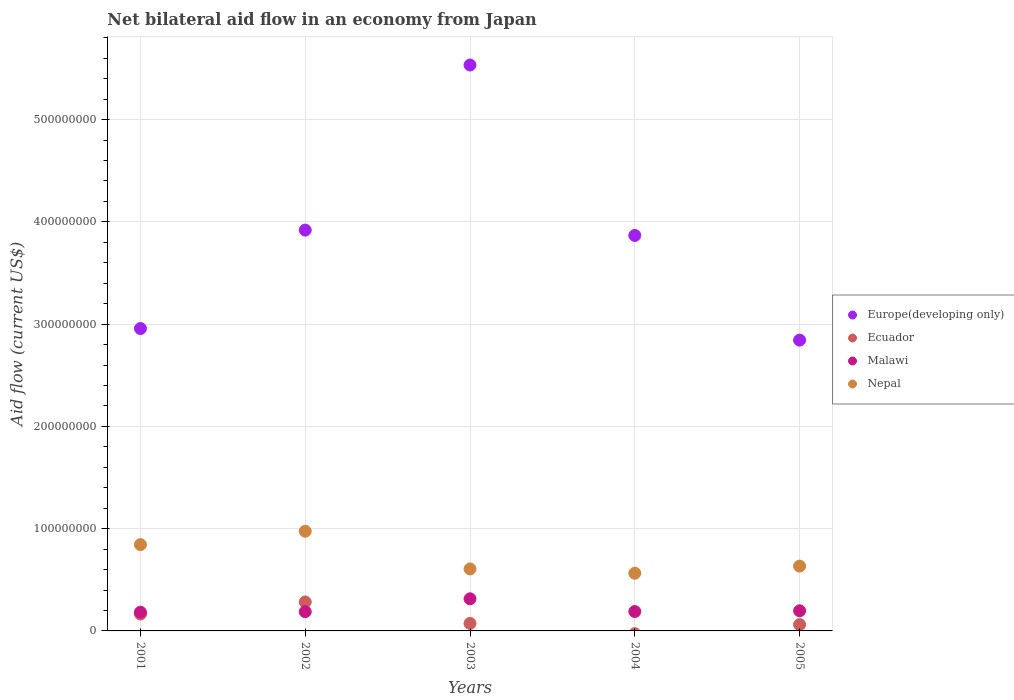How many different coloured dotlines are there?
Provide a short and direct response. 4. Is the number of dotlines equal to the number of legend labels?
Provide a succinct answer. No. What is the net bilateral aid flow in Europe(developing only) in 2003?
Make the answer very short. 5.53e+08. Across all years, what is the maximum net bilateral aid flow in Europe(developing only)?
Make the answer very short. 5.53e+08. Across all years, what is the minimum net bilateral aid flow in Nepal?
Your answer should be compact. 5.64e+07. What is the total net bilateral aid flow in Europe(developing only) in the graph?
Provide a short and direct response. 1.91e+09. What is the difference between the net bilateral aid flow in Europe(developing only) in 2002 and that in 2004?
Offer a terse response. 5.23e+06. What is the difference between the net bilateral aid flow in Malawi in 2002 and the net bilateral aid flow in Ecuador in 2001?
Make the answer very short. 2.27e+06. What is the average net bilateral aid flow in Malawi per year?
Make the answer very short. 2.14e+07. In the year 2001, what is the difference between the net bilateral aid flow in Malawi and net bilateral aid flow in Ecuador?
Keep it short and to the point. 1.75e+06. What is the ratio of the net bilateral aid flow in Nepal in 2003 to that in 2004?
Offer a very short reply. 1.07. Is the difference between the net bilateral aid flow in Malawi in 2001 and 2005 greater than the difference between the net bilateral aid flow in Ecuador in 2001 and 2005?
Your answer should be very brief. No. What is the difference between the highest and the second highest net bilateral aid flow in Nepal?
Ensure brevity in your answer.  1.31e+07. What is the difference between the highest and the lowest net bilateral aid flow in Nepal?
Your answer should be very brief. 4.10e+07. Is the sum of the net bilateral aid flow in Nepal in 2004 and 2005 greater than the maximum net bilateral aid flow in Malawi across all years?
Your response must be concise. Yes. Is it the case that in every year, the sum of the net bilateral aid flow in Europe(developing only) and net bilateral aid flow in Nepal  is greater than the net bilateral aid flow in Malawi?
Your response must be concise. Yes. Does the net bilateral aid flow in Europe(developing only) monotonically increase over the years?
Make the answer very short. No. How many years are there in the graph?
Ensure brevity in your answer.  5. What is the difference between two consecutive major ticks on the Y-axis?
Provide a short and direct response. 1.00e+08. Are the values on the major ticks of Y-axis written in scientific E-notation?
Ensure brevity in your answer.  No. Does the graph contain grids?
Provide a succinct answer. Yes. How many legend labels are there?
Provide a succinct answer. 4. What is the title of the graph?
Keep it short and to the point. Net bilateral aid flow in an economy from Japan. Does "Marshall Islands" appear as one of the legend labels in the graph?
Offer a terse response. No. What is the label or title of the X-axis?
Your answer should be compact. Years. What is the label or title of the Y-axis?
Provide a short and direct response. Aid flow (current US$). What is the Aid flow (current US$) in Europe(developing only) in 2001?
Ensure brevity in your answer.  2.96e+08. What is the Aid flow (current US$) in Ecuador in 2001?
Your response must be concise. 1.65e+07. What is the Aid flow (current US$) of Malawi in 2001?
Provide a succinct answer. 1.83e+07. What is the Aid flow (current US$) of Nepal in 2001?
Your answer should be very brief. 8.44e+07. What is the Aid flow (current US$) of Europe(developing only) in 2002?
Ensure brevity in your answer.  3.92e+08. What is the Aid flow (current US$) of Ecuador in 2002?
Provide a succinct answer. 2.83e+07. What is the Aid flow (current US$) in Malawi in 2002?
Provide a short and direct response. 1.88e+07. What is the Aid flow (current US$) in Nepal in 2002?
Your answer should be very brief. 9.74e+07. What is the Aid flow (current US$) of Europe(developing only) in 2003?
Ensure brevity in your answer.  5.53e+08. What is the Aid flow (current US$) of Ecuador in 2003?
Provide a succinct answer. 7.32e+06. What is the Aid flow (current US$) of Malawi in 2003?
Your answer should be compact. 3.14e+07. What is the Aid flow (current US$) in Nepal in 2003?
Your response must be concise. 6.06e+07. What is the Aid flow (current US$) of Europe(developing only) in 2004?
Your answer should be very brief. 3.87e+08. What is the Aid flow (current US$) in Malawi in 2004?
Your answer should be very brief. 1.90e+07. What is the Aid flow (current US$) in Nepal in 2004?
Offer a very short reply. 5.64e+07. What is the Aid flow (current US$) of Europe(developing only) in 2005?
Your response must be concise. 2.84e+08. What is the Aid flow (current US$) of Ecuador in 2005?
Provide a succinct answer. 6.17e+06. What is the Aid flow (current US$) of Malawi in 2005?
Give a very brief answer. 1.97e+07. What is the Aid flow (current US$) in Nepal in 2005?
Ensure brevity in your answer.  6.34e+07. Across all years, what is the maximum Aid flow (current US$) of Europe(developing only)?
Ensure brevity in your answer.  5.53e+08. Across all years, what is the maximum Aid flow (current US$) of Ecuador?
Make the answer very short. 2.83e+07. Across all years, what is the maximum Aid flow (current US$) of Malawi?
Offer a terse response. 3.14e+07. Across all years, what is the maximum Aid flow (current US$) of Nepal?
Your answer should be very brief. 9.74e+07. Across all years, what is the minimum Aid flow (current US$) of Europe(developing only)?
Offer a terse response. 2.84e+08. Across all years, what is the minimum Aid flow (current US$) of Malawi?
Offer a terse response. 1.83e+07. Across all years, what is the minimum Aid flow (current US$) of Nepal?
Give a very brief answer. 5.64e+07. What is the total Aid flow (current US$) of Europe(developing only) in the graph?
Your response must be concise. 1.91e+09. What is the total Aid flow (current US$) in Ecuador in the graph?
Keep it short and to the point. 5.83e+07. What is the total Aid flow (current US$) in Malawi in the graph?
Provide a short and direct response. 1.07e+08. What is the total Aid flow (current US$) in Nepal in the graph?
Provide a short and direct response. 3.62e+08. What is the difference between the Aid flow (current US$) in Europe(developing only) in 2001 and that in 2002?
Give a very brief answer. -9.63e+07. What is the difference between the Aid flow (current US$) in Ecuador in 2001 and that in 2002?
Offer a terse response. -1.18e+07. What is the difference between the Aid flow (current US$) in Malawi in 2001 and that in 2002?
Make the answer very short. -5.20e+05. What is the difference between the Aid flow (current US$) in Nepal in 2001 and that in 2002?
Your answer should be compact. -1.31e+07. What is the difference between the Aid flow (current US$) of Europe(developing only) in 2001 and that in 2003?
Your answer should be very brief. -2.58e+08. What is the difference between the Aid flow (current US$) in Ecuador in 2001 and that in 2003?
Give a very brief answer. 9.22e+06. What is the difference between the Aid flow (current US$) of Malawi in 2001 and that in 2003?
Offer a terse response. -1.31e+07. What is the difference between the Aid flow (current US$) in Nepal in 2001 and that in 2003?
Offer a very short reply. 2.38e+07. What is the difference between the Aid flow (current US$) of Europe(developing only) in 2001 and that in 2004?
Give a very brief answer. -9.10e+07. What is the difference between the Aid flow (current US$) in Malawi in 2001 and that in 2004?
Provide a short and direct response. -6.70e+05. What is the difference between the Aid flow (current US$) in Nepal in 2001 and that in 2004?
Your response must be concise. 2.80e+07. What is the difference between the Aid flow (current US$) of Europe(developing only) in 2001 and that in 2005?
Give a very brief answer. 1.13e+07. What is the difference between the Aid flow (current US$) in Ecuador in 2001 and that in 2005?
Your response must be concise. 1.04e+07. What is the difference between the Aid flow (current US$) of Malawi in 2001 and that in 2005?
Offer a very short reply. -1.41e+06. What is the difference between the Aid flow (current US$) in Nepal in 2001 and that in 2005?
Your response must be concise. 2.10e+07. What is the difference between the Aid flow (current US$) of Europe(developing only) in 2002 and that in 2003?
Give a very brief answer. -1.61e+08. What is the difference between the Aid flow (current US$) in Ecuador in 2002 and that in 2003?
Keep it short and to the point. 2.10e+07. What is the difference between the Aid flow (current US$) of Malawi in 2002 and that in 2003?
Give a very brief answer. -1.26e+07. What is the difference between the Aid flow (current US$) in Nepal in 2002 and that in 2003?
Your answer should be very brief. 3.68e+07. What is the difference between the Aid flow (current US$) of Europe(developing only) in 2002 and that in 2004?
Your answer should be compact. 5.23e+06. What is the difference between the Aid flow (current US$) of Nepal in 2002 and that in 2004?
Offer a terse response. 4.10e+07. What is the difference between the Aid flow (current US$) of Europe(developing only) in 2002 and that in 2005?
Keep it short and to the point. 1.08e+08. What is the difference between the Aid flow (current US$) in Ecuador in 2002 and that in 2005?
Offer a very short reply. 2.21e+07. What is the difference between the Aid flow (current US$) in Malawi in 2002 and that in 2005?
Give a very brief answer. -8.90e+05. What is the difference between the Aid flow (current US$) in Nepal in 2002 and that in 2005?
Your answer should be compact. 3.41e+07. What is the difference between the Aid flow (current US$) in Europe(developing only) in 2003 and that in 2004?
Offer a very short reply. 1.67e+08. What is the difference between the Aid flow (current US$) in Malawi in 2003 and that in 2004?
Provide a short and direct response. 1.24e+07. What is the difference between the Aid flow (current US$) of Nepal in 2003 and that in 2004?
Make the answer very short. 4.18e+06. What is the difference between the Aid flow (current US$) of Europe(developing only) in 2003 and that in 2005?
Ensure brevity in your answer.  2.69e+08. What is the difference between the Aid flow (current US$) of Ecuador in 2003 and that in 2005?
Offer a terse response. 1.15e+06. What is the difference between the Aid flow (current US$) of Malawi in 2003 and that in 2005?
Offer a terse response. 1.17e+07. What is the difference between the Aid flow (current US$) of Nepal in 2003 and that in 2005?
Ensure brevity in your answer.  -2.77e+06. What is the difference between the Aid flow (current US$) of Europe(developing only) in 2004 and that in 2005?
Make the answer very short. 1.02e+08. What is the difference between the Aid flow (current US$) in Malawi in 2004 and that in 2005?
Make the answer very short. -7.40e+05. What is the difference between the Aid flow (current US$) of Nepal in 2004 and that in 2005?
Give a very brief answer. -6.95e+06. What is the difference between the Aid flow (current US$) in Europe(developing only) in 2001 and the Aid flow (current US$) in Ecuador in 2002?
Offer a very short reply. 2.67e+08. What is the difference between the Aid flow (current US$) of Europe(developing only) in 2001 and the Aid flow (current US$) of Malawi in 2002?
Your answer should be compact. 2.77e+08. What is the difference between the Aid flow (current US$) of Europe(developing only) in 2001 and the Aid flow (current US$) of Nepal in 2002?
Your answer should be very brief. 1.98e+08. What is the difference between the Aid flow (current US$) in Ecuador in 2001 and the Aid flow (current US$) in Malawi in 2002?
Your response must be concise. -2.27e+06. What is the difference between the Aid flow (current US$) in Ecuador in 2001 and the Aid flow (current US$) in Nepal in 2002?
Give a very brief answer. -8.09e+07. What is the difference between the Aid flow (current US$) in Malawi in 2001 and the Aid flow (current US$) in Nepal in 2002?
Offer a very short reply. -7.92e+07. What is the difference between the Aid flow (current US$) of Europe(developing only) in 2001 and the Aid flow (current US$) of Ecuador in 2003?
Provide a short and direct response. 2.88e+08. What is the difference between the Aid flow (current US$) in Europe(developing only) in 2001 and the Aid flow (current US$) in Malawi in 2003?
Ensure brevity in your answer.  2.64e+08. What is the difference between the Aid flow (current US$) in Europe(developing only) in 2001 and the Aid flow (current US$) in Nepal in 2003?
Ensure brevity in your answer.  2.35e+08. What is the difference between the Aid flow (current US$) in Ecuador in 2001 and the Aid flow (current US$) in Malawi in 2003?
Provide a succinct answer. -1.49e+07. What is the difference between the Aid flow (current US$) in Ecuador in 2001 and the Aid flow (current US$) in Nepal in 2003?
Ensure brevity in your answer.  -4.41e+07. What is the difference between the Aid flow (current US$) of Malawi in 2001 and the Aid flow (current US$) of Nepal in 2003?
Make the answer very short. -4.23e+07. What is the difference between the Aid flow (current US$) of Europe(developing only) in 2001 and the Aid flow (current US$) of Malawi in 2004?
Your answer should be compact. 2.77e+08. What is the difference between the Aid flow (current US$) in Europe(developing only) in 2001 and the Aid flow (current US$) in Nepal in 2004?
Provide a succinct answer. 2.39e+08. What is the difference between the Aid flow (current US$) in Ecuador in 2001 and the Aid flow (current US$) in Malawi in 2004?
Your response must be concise. -2.42e+06. What is the difference between the Aid flow (current US$) of Ecuador in 2001 and the Aid flow (current US$) of Nepal in 2004?
Make the answer very short. -3.99e+07. What is the difference between the Aid flow (current US$) of Malawi in 2001 and the Aid flow (current US$) of Nepal in 2004?
Your answer should be very brief. -3.81e+07. What is the difference between the Aid flow (current US$) in Europe(developing only) in 2001 and the Aid flow (current US$) in Ecuador in 2005?
Offer a terse response. 2.90e+08. What is the difference between the Aid flow (current US$) in Europe(developing only) in 2001 and the Aid flow (current US$) in Malawi in 2005?
Provide a succinct answer. 2.76e+08. What is the difference between the Aid flow (current US$) of Europe(developing only) in 2001 and the Aid flow (current US$) of Nepal in 2005?
Provide a short and direct response. 2.32e+08. What is the difference between the Aid flow (current US$) in Ecuador in 2001 and the Aid flow (current US$) in Malawi in 2005?
Keep it short and to the point. -3.16e+06. What is the difference between the Aid flow (current US$) of Ecuador in 2001 and the Aid flow (current US$) of Nepal in 2005?
Offer a terse response. -4.68e+07. What is the difference between the Aid flow (current US$) of Malawi in 2001 and the Aid flow (current US$) of Nepal in 2005?
Your response must be concise. -4.51e+07. What is the difference between the Aid flow (current US$) in Europe(developing only) in 2002 and the Aid flow (current US$) in Ecuador in 2003?
Your answer should be compact. 3.85e+08. What is the difference between the Aid flow (current US$) in Europe(developing only) in 2002 and the Aid flow (current US$) in Malawi in 2003?
Offer a terse response. 3.61e+08. What is the difference between the Aid flow (current US$) in Europe(developing only) in 2002 and the Aid flow (current US$) in Nepal in 2003?
Offer a terse response. 3.31e+08. What is the difference between the Aid flow (current US$) of Ecuador in 2002 and the Aid flow (current US$) of Malawi in 2003?
Give a very brief answer. -3.12e+06. What is the difference between the Aid flow (current US$) in Ecuador in 2002 and the Aid flow (current US$) in Nepal in 2003?
Your response must be concise. -3.23e+07. What is the difference between the Aid flow (current US$) of Malawi in 2002 and the Aid flow (current US$) of Nepal in 2003?
Give a very brief answer. -4.18e+07. What is the difference between the Aid flow (current US$) of Europe(developing only) in 2002 and the Aid flow (current US$) of Malawi in 2004?
Provide a succinct answer. 3.73e+08. What is the difference between the Aid flow (current US$) of Europe(developing only) in 2002 and the Aid flow (current US$) of Nepal in 2004?
Provide a short and direct response. 3.36e+08. What is the difference between the Aid flow (current US$) in Ecuador in 2002 and the Aid flow (current US$) in Malawi in 2004?
Provide a succinct answer. 9.33e+06. What is the difference between the Aid flow (current US$) in Ecuador in 2002 and the Aid flow (current US$) in Nepal in 2004?
Ensure brevity in your answer.  -2.81e+07. What is the difference between the Aid flow (current US$) in Malawi in 2002 and the Aid flow (current US$) in Nepal in 2004?
Make the answer very short. -3.76e+07. What is the difference between the Aid flow (current US$) of Europe(developing only) in 2002 and the Aid flow (current US$) of Ecuador in 2005?
Offer a very short reply. 3.86e+08. What is the difference between the Aid flow (current US$) in Europe(developing only) in 2002 and the Aid flow (current US$) in Malawi in 2005?
Your response must be concise. 3.72e+08. What is the difference between the Aid flow (current US$) of Europe(developing only) in 2002 and the Aid flow (current US$) of Nepal in 2005?
Keep it short and to the point. 3.29e+08. What is the difference between the Aid flow (current US$) of Ecuador in 2002 and the Aid flow (current US$) of Malawi in 2005?
Give a very brief answer. 8.59e+06. What is the difference between the Aid flow (current US$) in Ecuador in 2002 and the Aid flow (current US$) in Nepal in 2005?
Your answer should be very brief. -3.51e+07. What is the difference between the Aid flow (current US$) of Malawi in 2002 and the Aid flow (current US$) of Nepal in 2005?
Make the answer very short. -4.46e+07. What is the difference between the Aid flow (current US$) of Europe(developing only) in 2003 and the Aid flow (current US$) of Malawi in 2004?
Your answer should be very brief. 5.34e+08. What is the difference between the Aid flow (current US$) in Europe(developing only) in 2003 and the Aid flow (current US$) in Nepal in 2004?
Make the answer very short. 4.97e+08. What is the difference between the Aid flow (current US$) of Ecuador in 2003 and the Aid flow (current US$) of Malawi in 2004?
Offer a very short reply. -1.16e+07. What is the difference between the Aid flow (current US$) of Ecuador in 2003 and the Aid flow (current US$) of Nepal in 2004?
Keep it short and to the point. -4.91e+07. What is the difference between the Aid flow (current US$) of Malawi in 2003 and the Aid flow (current US$) of Nepal in 2004?
Keep it short and to the point. -2.50e+07. What is the difference between the Aid flow (current US$) of Europe(developing only) in 2003 and the Aid flow (current US$) of Ecuador in 2005?
Your answer should be very brief. 5.47e+08. What is the difference between the Aid flow (current US$) of Europe(developing only) in 2003 and the Aid flow (current US$) of Malawi in 2005?
Provide a succinct answer. 5.34e+08. What is the difference between the Aid flow (current US$) in Europe(developing only) in 2003 and the Aid flow (current US$) in Nepal in 2005?
Give a very brief answer. 4.90e+08. What is the difference between the Aid flow (current US$) in Ecuador in 2003 and the Aid flow (current US$) in Malawi in 2005?
Give a very brief answer. -1.24e+07. What is the difference between the Aid flow (current US$) in Ecuador in 2003 and the Aid flow (current US$) in Nepal in 2005?
Provide a succinct answer. -5.61e+07. What is the difference between the Aid flow (current US$) of Malawi in 2003 and the Aid flow (current US$) of Nepal in 2005?
Provide a short and direct response. -3.20e+07. What is the difference between the Aid flow (current US$) in Europe(developing only) in 2004 and the Aid flow (current US$) in Ecuador in 2005?
Ensure brevity in your answer.  3.81e+08. What is the difference between the Aid flow (current US$) in Europe(developing only) in 2004 and the Aid flow (current US$) in Malawi in 2005?
Your response must be concise. 3.67e+08. What is the difference between the Aid flow (current US$) of Europe(developing only) in 2004 and the Aid flow (current US$) of Nepal in 2005?
Make the answer very short. 3.23e+08. What is the difference between the Aid flow (current US$) in Malawi in 2004 and the Aid flow (current US$) in Nepal in 2005?
Keep it short and to the point. -4.44e+07. What is the average Aid flow (current US$) in Europe(developing only) per year?
Ensure brevity in your answer.  3.82e+08. What is the average Aid flow (current US$) in Ecuador per year?
Offer a very short reply. 1.17e+07. What is the average Aid flow (current US$) of Malawi per year?
Provide a succinct answer. 2.14e+07. What is the average Aid flow (current US$) in Nepal per year?
Provide a succinct answer. 7.25e+07. In the year 2001, what is the difference between the Aid flow (current US$) in Europe(developing only) and Aid flow (current US$) in Ecuador?
Ensure brevity in your answer.  2.79e+08. In the year 2001, what is the difference between the Aid flow (current US$) in Europe(developing only) and Aid flow (current US$) in Malawi?
Your answer should be very brief. 2.77e+08. In the year 2001, what is the difference between the Aid flow (current US$) in Europe(developing only) and Aid flow (current US$) in Nepal?
Offer a very short reply. 2.11e+08. In the year 2001, what is the difference between the Aid flow (current US$) in Ecuador and Aid flow (current US$) in Malawi?
Ensure brevity in your answer.  -1.75e+06. In the year 2001, what is the difference between the Aid flow (current US$) of Ecuador and Aid flow (current US$) of Nepal?
Your answer should be compact. -6.78e+07. In the year 2001, what is the difference between the Aid flow (current US$) of Malawi and Aid flow (current US$) of Nepal?
Offer a very short reply. -6.61e+07. In the year 2002, what is the difference between the Aid flow (current US$) of Europe(developing only) and Aid flow (current US$) of Ecuador?
Keep it short and to the point. 3.64e+08. In the year 2002, what is the difference between the Aid flow (current US$) of Europe(developing only) and Aid flow (current US$) of Malawi?
Your answer should be compact. 3.73e+08. In the year 2002, what is the difference between the Aid flow (current US$) in Europe(developing only) and Aid flow (current US$) in Nepal?
Your answer should be compact. 2.94e+08. In the year 2002, what is the difference between the Aid flow (current US$) in Ecuador and Aid flow (current US$) in Malawi?
Provide a short and direct response. 9.48e+06. In the year 2002, what is the difference between the Aid flow (current US$) in Ecuador and Aid flow (current US$) in Nepal?
Provide a short and direct response. -6.92e+07. In the year 2002, what is the difference between the Aid flow (current US$) in Malawi and Aid flow (current US$) in Nepal?
Make the answer very short. -7.86e+07. In the year 2003, what is the difference between the Aid flow (current US$) of Europe(developing only) and Aid flow (current US$) of Ecuador?
Keep it short and to the point. 5.46e+08. In the year 2003, what is the difference between the Aid flow (current US$) of Europe(developing only) and Aid flow (current US$) of Malawi?
Provide a succinct answer. 5.22e+08. In the year 2003, what is the difference between the Aid flow (current US$) of Europe(developing only) and Aid flow (current US$) of Nepal?
Ensure brevity in your answer.  4.93e+08. In the year 2003, what is the difference between the Aid flow (current US$) of Ecuador and Aid flow (current US$) of Malawi?
Your answer should be very brief. -2.41e+07. In the year 2003, what is the difference between the Aid flow (current US$) in Ecuador and Aid flow (current US$) in Nepal?
Ensure brevity in your answer.  -5.33e+07. In the year 2003, what is the difference between the Aid flow (current US$) in Malawi and Aid flow (current US$) in Nepal?
Your answer should be very brief. -2.92e+07. In the year 2004, what is the difference between the Aid flow (current US$) of Europe(developing only) and Aid flow (current US$) of Malawi?
Your answer should be very brief. 3.68e+08. In the year 2004, what is the difference between the Aid flow (current US$) of Europe(developing only) and Aid flow (current US$) of Nepal?
Offer a very short reply. 3.30e+08. In the year 2004, what is the difference between the Aid flow (current US$) in Malawi and Aid flow (current US$) in Nepal?
Your answer should be very brief. -3.75e+07. In the year 2005, what is the difference between the Aid flow (current US$) in Europe(developing only) and Aid flow (current US$) in Ecuador?
Offer a terse response. 2.78e+08. In the year 2005, what is the difference between the Aid flow (current US$) in Europe(developing only) and Aid flow (current US$) in Malawi?
Give a very brief answer. 2.65e+08. In the year 2005, what is the difference between the Aid flow (current US$) of Europe(developing only) and Aid flow (current US$) of Nepal?
Give a very brief answer. 2.21e+08. In the year 2005, what is the difference between the Aid flow (current US$) in Ecuador and Aid flow (current US$) in Malawi?
Provide a short and direct response. -1.35e+07. In the year 2005, what is the difference between the Aid flow (current US$) in Ecuador and Aid flow (current US$) in Nepal?
Offer a very short reply. -5.72e+07. In the year 2005, what is the difference between the Aid flow (current US$) of Malawi and Aid flow (current US$) of Nepal?
Your response must be concise. -4.37e+07. What is the ratio of the Aid flow (current US$) of Europe(developing only) in 2001 to that in 2002?
Offer a very short reply. 0.75. What is the ratio of the Aid flow (current US$) in Ecuador in 2001 to that in 2002?
Provide a short and direct response. 0.58. What is the ratio of the Aid flow (current US$) in Malawi in 2001 to that in 2002?
Provide a succinct answer. 0.97. What is the ratio of the Aid flow (current US$) of Nepal in 2001 to that in 2002?
Keep it short and to the point. 0.87. What is the ratio of the Aid flow (current US$) in Europe(developing only) in 2001 to that in 2003?
Provide a short and direct response. 0.53. What is the ratio of the Aid flow (current US$) in Ecuador in 2001 to that in 2003?
Make the answer very short. 2.26. What is the ratio of the Aid flow (current US$) of Malawi in 2001 to that in 2003?
Your answer should be very brief. 0.58. What is the ratio of the Aid flow (current US$) of Nepal in 2001 to that in 2003?
Offer a terse response. 1.39. What is the ratio of the Aid flow (current US$) in Europe(developing only) in 2001 to that in 2004?
Ensure brevity in your answer.  0.76. What is the ratio of the Aid flow (current US$) in Malawi in 2001 to that in 2004?
Your answer should be very brief. 0.96. What is the ratio of the Aid flow (current US$) of Nepal in 2001 to that in 2004?
Ensure brevity in your answer.  1.5. What is the ratio of the Aid flow (current US$) of Europe(developing only) in 2001 to that in 2005?
Make the answer very short. 1.04. What is the ratio of the Aid flow (current US$) in Ecuador in 2001 to that in 2005?
Your answer should be compact. 2.68. What is the ratio of the Aid flow (current US$) of Malawi in 2001 to that in 2005?
Give a very brief answer. 0.93. What is the ratio of the Aid flow (current US$) of Nepal in 2001 to that in 2005?
Ensure brevity in your answer.  1.33. What is the ratio of the Aid flow (current US$) in Europe(developing only) in 2002 to that in 2003?
Your answer should be compact. 0.71. What is the ratio of the Aid flow (current US$) of Ecuador in 2002 to that in 2003?
Provide a succinct answer. 3.86. What is the ratio of the Aid flow (current US$) in Malawi in 2002 to that in 2003?
Your response must be concise. 0.6. What is the ratio of the Aid flow (current US$) in Nepal in 2002 to that in 2003?
Your answer should be very brief. 1.61. What is the ratio of the Aid flow (current US$) of Europe(developing only) in 2002 to that in 2004?
Provide a short and direct response. 1.01. What is the ratio of the Aid flow (current US$) in Malawi in 2002 to that in 2004?
Give a very brief answer. 0.99. What is the ratio of the Aid flow (current US$) in Nepal in 2002 to that in 2004?
Your answer should be compact. 1.73. What is the ratio of the Aid flow (current US$) in Europe(developing only) in 2002 to that in 2005?
Keep it short and to the point. 1.38. What is the ratio of the Aid flow (current US$) of Ecuador in 2002 to that in 2005?
Provide a short and direct response. 4.59. What is the ratio of the Aid flow (current US$) of Malawi in 2002 to that in 2005?
Keep it short and to the point. 0.95. What is the ratio of the Aid flow (current US$) in Nepal in 2002 to that in 2005?
Offer a very short reply. 1.54. What is the ratio of the Aid flow (current US$) of Europe(developing only) in 2003 to that in 2004?
Give a very brief answer. 1.43. What is the ratio of the Aid flow (current US$) in Malawi in 2003 to that in 2004?
Offer a terse response. 1.66. What is the ratio of the Aid flow (current US$) of Nepal in 2003 to that in 2004?
Provide a succinct answer. 1.07. What is the ratio of the Aid flow (current US$) in Europe(developing only) in 2003 to that in 2005?
Offer a very short reply. 1.95. What is the ratio of the Aid flow (current US$) in Ecuador in 2003 to that in 2005?
Ensure brevity in your answer.  1.19. What is the ratio of the Aid flow (current US$) in Malawi in 2003 to that in 2005?
Your answer should be very brief. 1.59. What is the ratio of the Aid flow (current US$) of Nepal in 2003 to that in 2005?
Provide a succinct answer. 0.96. What is the ratio of the Aid flow (current US$) in Europe(developing only) in 2004 to that in 2005?
Provide a succinct answer. 1.36. What is the ratio of the Aid flow (current US$) of Malawi in 2004 to that in 2005?
Offer a terse response. 0.96. What is the ratio of the Aid flow (current US$) of Nepal in 2004 to that in 2005?
Offer a terse response. 0.89. What is the difference between the highest and the second highest Aid flow (current US$) of Europe(developing only)?
Make the answer very short. 1.61e+08. What is the difference between the highest and the second highest Aid flow (current US$) of Ecuador?
Make the answer very short. 1.18e+07. What is the difference between the highest and the second highest Aid flow (current US$) of Malawi?
Offer a very short reply. 1.17e+07. What is the difference between the highest and the second highest Aid flow (current US$) of Nepal?
Your response must be concise. 1.31e+07. What is the difference between the highest and the lowest Aid flow (current US$) of Europe(developing only)?
Offer a very short reply. 2.69e+08. What is the difference between the highest and the lowest Aid flow (current US$) of Ecuador?
Ensure brevity in your answer.  2.83e+07. What is the difference between the highest and the lowest Aid flow (current US$) in Malawi?
Give a very brief answer. 1.31e+07. What is the difference between the highest and the lowest Aid flow (current US$) in Nepal?
Give a very brief answer. 4.10e+07. 